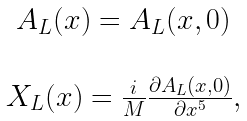<formula> <loc_0><loc_0><loc_500><loc_500>\begin{array} { c } A _ { L } ( x ) = A _ { L } ( x , 0 ) \\ \\ X _ { L } ( x ) = \frac { i } { M } \frac { \partial A _ { L } ( x , 0 ) } { \partial x ^ { 5 } } , \\ \end{array}</formula> 